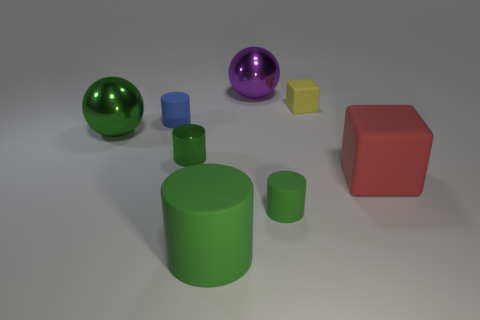What number of objects are either big metal objects in front of the tiny yellow rubber object or metal balls that are on the right side of the big green metallic thing?
Ensure brevity in your answer.  2. There is a green metallic object that is the same size as the yellow object; what is its shape?
Make the answer very short. Cylinder. There is a small matte object that is in front of the metal ball that is on the left side of the large metal object that is on the right side of the metal cylinder; what shape is it?
Offer a terse response. Cylinder. Are there an equal number of small blue matte cylinders to the right of the green metal cylinder and big purple blocks?
Keep it short and to the point. Yes. Do the purple metal sphere and the yellow rubber cube have the same size?
Ensure brevity in your answer.  No. How many metallic objects are either red blocks or large purple cubes?
Offer a terse response. 0. There is a block that is the same size as the blue cylinder; what is it made of?
Keep it short and to the point. Rubber. What number of other things are made of the same material as the tiny cube?
Your answer should be compact. 4. Is the number of balls in front of the red rubber object less than the number of small green cylinders?
Offer a terse response. Yes. Do the big red matte thing and the blue rubber thing have the same shape?
Your response must be concise. No. 